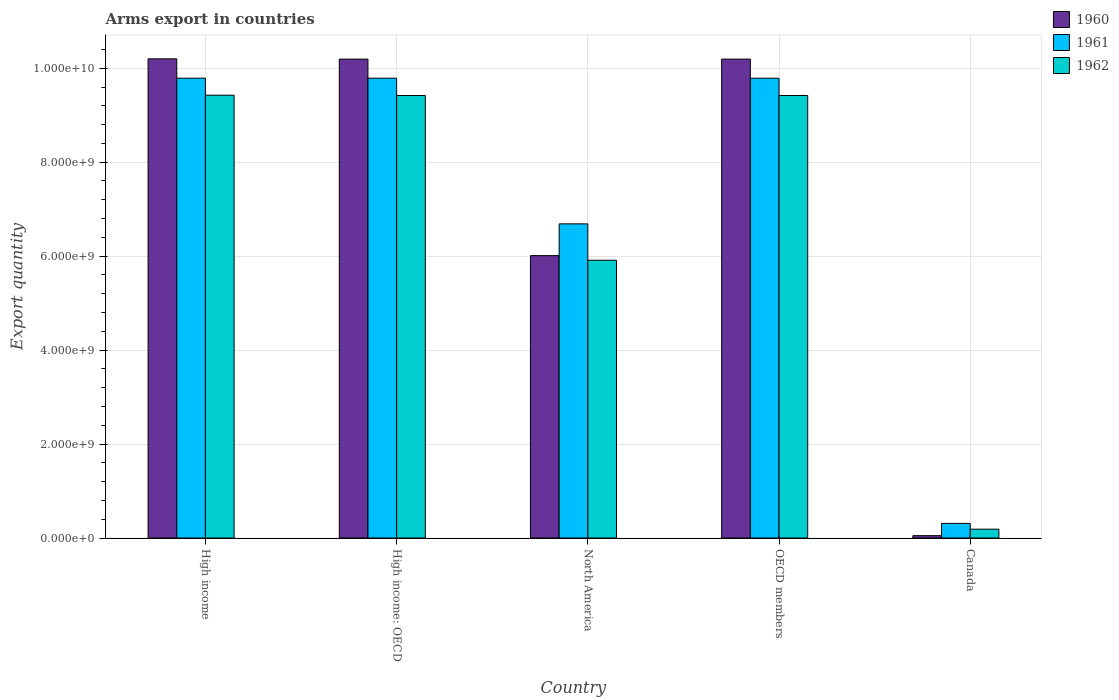Are the number of bars per tick equal to the number of legend labels?
Keep it short and to the point. Yes. How many bars are there on the 1st tick from the left?
Your response must be concise. 3. What is the label of the 3rd group of bars from the left?
Your answer should be compact. North America. What is the total arms export in 1962 in High income?
Provide a succinct answer. 9.43e+09. Across all countries, what is the maximum total arms export in 1961?
Offer a very short reply. 9.79e+09. Across all countries, what is the minimum total arms export in 1960?
Keep it short and to the point. 5.00e+07. In which country was the total arms export in 1962 minimum?
Your answer should be compact. Canada. What is the total total arms export in 1961 in the graph?
Your answer should be compact. 3.64e+1. What is the difference between the total arms export in 1961 in High income and that in OECD members?
Your response must be concise. 0. What is the difference between the total arms export in 1960 in High income and the total arms export in 1962 in North America?
Your answer should be very brief. 4.29e+09. What is the average total arms export in 1962 per country?
Make the answer very short. 6.87e+09. What is the difference between the total arms export of/in 1961 and total arms export of/in 1960 in Canada?
Your answer should be compact. 2.61e+08. In how many countries, is the total arms export in 1962 greater than 7600000000?
Keep it short and to the point. 3. What is the ratio of the total arms export in 1962 in High income to that in OECD members?
Offer a very short reply. 1. Is the difference between the total arms export in 1961 in Canada and North America greater than the difference between the total arms export in 1960 in Canada and North America?
Give a very brief answer. No. What is the difference between the highest and the lowest total arms export in 1960?
Give a very brief answer. 1.02e+1. In how many countries, is the total arms export in 1960 greater than the average total arms export in 1960 taken over all countries?
Keep it short and to the point. 3. Is it the case that in every country, the sum of the total arms export in 1960 and total arms export in 1962 is greater than the total arms export in 1961?
Your response must be concise. No. How many bars are there?
Offer a very short reply. 15. Are all the bars in the graph horizontal?
Make the answer very short. No. Are the values on the major ticks of Y-axis written in scientific E-notation?
Provide a succinct answer. Yes. How many legend labels are there?
Make the answer very short. 3. What is the title of the graph?
Ensure brevity in your answer.  Arms export in countries. Does "2007" appear as one of the legend labels in the graph?
Provide a succinct answer. No. What is the label or title of the Y-axis?
Offer a terse response. Export quantity. What is the Export quantity of 1960 in High income?
Your answer should be very brief. 1.02e+1. What is the Export quantity in 1961 in High income?
Make the answer very short. 9.79e+09. What is the Export quantity in 1962 in High income?
Give a very brief answer. 9.43e+09. What is the Export quantity in 1960 in High income: OECD?
Your answer should be very brief. 1.02e+1. What is the Export quantity of 1961 in High income: OECD?
Your response must be concise. 9.79e+09. What is the Export quantity of 1962 in High income: OECD?
Your answer should be very brief. 9.42e+09. What is the Export quantity of 1960 in North America?
Give a very brief answer. 6.01e+09. What is the Export quantity in 1961 in North America?
Make the answer very short. 6.69e+09. What is the Export quantity of 1962 in North America?
Provide a short and direct response. 5.91e+09. What is the Export quantity of 1960 in OECD members?
Make the answer very short. 1.02e+1. What is the Export quantity of 1961 in OECD members?
Keep it short and to the point. 9.79e+09. What is the Export quantity in 1962 in OECD members?
Make the answer very short. 9.42e+09. What is the Export quantity in 1961 in Canada?
Your response must be concise. 3.11e+08. What is the Export quantity of 1962 in Canada?
Provide a short and direct response. 1.88e+08. Across all countries, what is the maximum Export quantity of 1960?
Your response must be concise. 1.02e+1. Across all countries, what is the maximum Export quantity of 1961?
Your answer should be very brief. 9.79e+09. Across all countries, what is the maximum Export quantity of 1962?
Give a very brief answer. 9.43e+09. Across all countries, what is the minimum Export quantity in 1960?
Give a very brief answer. 5.00e+07. Across all countries, what is the minimum Export quantity of 1961?
Offer a terse response. 3.11e+08. Across all countries, what is the minimum Export quantity of 1962?
Provide a succinct answer. 1.88e+08. What is the total Export quantity in 1960 in the graph?
Your answer should be very brief. 3.66e+1. What is the total Export quantity in 1961 in the graph?
Provide a short and direct response. 3.64e+1. What is the total Export quantity in 1962 in the graph?
Provide a succinct answer. 3.44e+1. What is the difference between the Export quantity of 1961 in High income and that in High income: OECD?
Give a very brief answer. 0. What is the difference between the Export quantity in 1962 in High income and that in High income: OECD?
Provide a succinct answer. 6.00e+06. What is the difference between the Export quantity in 1960 in High income and that in North America?
Your response must be concise. 4.19e+09. What is the difference between the Export quantity of 1961 in High income and that in North America?
Ensure brevity in your answer.  3.10e+09. What is the difference between the Export quantity of 1962 in High income and that in North America?
Keep it short and to the point. 3.51e+09. What is the difference between the Export quantity in 1960 in High income and that in OECD members?
Keep it short and to the point. 6.00e+06. What is the difference between the Export quantity in 1962 in High income and that in OECD members?
Keep it short and to the point. 6.00e+06. What is the difference between the Export quantity in 1960 in High income and that in Canada?
Your response must be concise. 1.02e+1. What is the difference between the Export quantity in 1961 in High income and that in Canada?
Offer a terse response. 9.48e+09. What is the difference between the Export quantity of 1962 in High income and that in Canada?
Provide a short and direct response. 9.24e+09. What is the difference between the Export quantity of 1960 in High income: OECD and that in North America?
Your response must be concise. 4.18e+09. What is the difference between the Export quantity of 1961 in High income: OECD and that in North America?
Provide a short and direct response. 3.10e+09. What is the difference between the Export quantity in 1962 in High income: OECD and that in North America?
Your answer should be very brief. 3.51e+09. What is the difference between the Export quantity of 1960 in High income: OECD and that in OECD members?
Offer a very short reply. 0. What is the difference between the Export quantity of 1962 in High income: OECD and that in OECD members?
Provide a short and direct response. 0. What is the difference between the Export quantity in 1960 in High income: OECD and that in Canada?
Provide a succinct answer. 1.01e+1. What is the difference between the Export quantity of 1961 in High income: OECD and that in Canada?
Give a very brief answer. 9.48e+09. What is the difference between the Export quantity in 1962 in High income: OECD and that in Canada?
Give a very brief answer. 9.23e+09. What is the difference between the Export quantity of 1960 in North America and that in OECD members?
Your answer should be very brief. -4.18e+09. What is the difference between the Export quantity in 1961 in North America and that in OECD members?
Offer a very short reply. -3.10e+09. What is the difference between the Export quantity of 1962 in North America and that in OECD members?
Provide a short and direct response. -3.51e+09. What is the difference between the Export quantity in 1960 in North America and that in Canada?
Ensure brevity in your answer.  5.96e+09. What is the difference between the Export quantity of 1961 in North America and that in Canada?
Provide a succinct answer. 6.38e+09. What is the difference between the Export quantity of 1962 in North America and that in Canada?
Your answer should be very brief. 5.72e+09. What is the difference between the Export quantity in 1960 in OECD members and that in Canada?
Give a very brief answer. 1.01e+1. What is the difference between the Export quantity in 1961 in OECD members and that in Canada?
Ensure brevity in your answer.  9.48e+09. What is the difference between the Export quantity of 1962 in OECD members and that in Canada?
Offer a very short reply. 9.23e+09. What is the difference between the Export quantity in 1960 in High income and the Export quantity in 1961 in High income: OECD?
Offer a terse response. 4.12e+08. What is the difference between the Export quantity in 1960 in High income and the Export quantity in 1962 in High income: OECD?
Ensure brevity in your answer.  7.80e+08. What is the difference between the Export quantity in 1961 in High income and the Export quantity in 1962 in High income: OECD?
Your answer should be compact. 3.68e+08. What is the difference between the Export quantity of 1960 in High income and the Export quantity of 1961 in North America?
Your answer should be very brief. 3.51e+09. What is the difference between the Export quantity of 1960 in High income and the Export quantity of 1962 in North America?
Provide a short and direct response. 4.29e+09. What is the difference between the Export quantity of 1961 in High income and the Export quantity of 1962 in North America?
Provide a succinct answer. 3.88e+09. What is the difference between the Export quantity in 1960 in High income and the Export quantity in 1961 in OECD members?
Offer a very short reply. 4.12e+08. What is the difference between the Export quantity in 1960 in High income and the Export quantity in 1962 in OECD members?
Your response must be concise. 7.80e+08. What is the difference between the Export quantity of 1961 in High income and the Export quantity of 1962 in OECD members?
Provide a short and direct response. 3.68e+08. What is the difference between the Export quantity of 1960 in High income and the Export quantity of 1961 in Canada?
Keep it short and to the point. 9.89e+09. What is the difference between the Export quantity of 1960 in High income and the Export quantity of 1962 in Canada?
Your answer should be compact. 1.00e+1. What is the difference between the Export quantity in 1961 in High income and the Export quantity in 1962 in Canada?
Make the answer very short. 9.60e+09. What is the difference between the Export quantity of 1960 in High income: OECD and the Export quantity of 1961 in North America?
Offer a very short reply. 3.51e+09. What is the difference between the Export quantity of 1960 in High income: OECD and the Export quantity of 1962 in North America?
Ensure brevity in your answer.  4.28e+09. What is the difference between the Export quantity of 1961 in High income: OECD and the Export quantity of 1962 in North America?
Ensure brevity in your answer.  3.88e+09. What is the difference between the Export quantity in 1960 in High income: OECD and the Export quantity in 1961 in OECD members?
Provide a succinct answer. 4.06e+08. What is the difference between the Export quantity of 1960 in High income: OECD and the Export quantity of 1962 in OECD members?
Offer a very short reply. 7.74e+08. What is the difference between the Export quantity in 1961 in High income: OECD and the Export quantity in 1962 in OECD members?
Ensure brevity in your answer.  3.68e+08. What is the difference between the Export quantity of 1960 in High income: OECD and the Export quantity of 1961 in Canada?
Provide a succinct answer. 9.88e+09. What is the difference between the Export quantity of 1960 in High income: OECD and the Export quantity of 1962 in Canada?
Keep it short and to the point. 1.00e+1. What is the difference between the Export quantity of 1961 in High income: OECD and the Export quantity of 1962 in Canada?
Give a very brief answer. 9.60e+09. What is the difference between the Export quantity of 1960 in North America and the Export quantity of 1961 in OECD members?
Provide a succinct answer. -3.78e+09. What is the difference between the Export quantity of 1960 in North America and the Export quantity of 1962 in OECD members?
Your answer should be compact. -3.41e+09. What is the difference between the Export quantity of 1961 in North America and the Export quantity of 1962 in OECD members?
Make the answer very short. -2.73e+09. What is the difference between the Export quantity in 1960 in North America and the Export quantity in 1961 in Canada?
Ensure brevity in your answer.  5.70e+09. What is the difference between the Export quantity in 1960 in North America and the Export quantity in 1962 in Canada?
Your response must be concise. 5.82e+09. What is the difference between the Export quantity of 1961 in North America and the Export quantity of 1962 in Canada?
Offer a very short reply. 6.50e+09. What is the difference between the Export quantity of 1960 in OECD members and the Export quantity of 1961 in Canada?
Your answer should be very brief. 9.88e+09. What is the difference between the Export quantity of 1960 in OECD members and the Export quantity of 1962 in Canada?
Make the answer very short. 1.00e+1. What is the difference between the Export quantity of 1961 in OECD members and the Export quantity of 1962 in Canada?
Provide a succinct answer. 9.60e+09. What is the average Export quantity of 1960 per country?
Ensure brevity in your answer.  7.33e+09. What is the average Export quantity in 1961 per country?
Make the answer very short. 7.27e+09. What is the average Export quantity of 1962 per country?
Keep it short and to the point. 6.87e+09. What is the difference between the Export quantity in 1960 and Export quantity in 1961 in High income?
Your answer should be very brief. 4.12e+08. What is the difference between the Export quantity of 1960 and Export quantity of 1962 in High income?
Provide a succinct answer. 7.74e+08. What is the difference between the Export quantity in 1961 and Export quantity in 1962 in High income?
Your answer should be compact. 3.62e+08. What is the difference between the Export quantity in 1960 and Export quantity in 1961 in High income: OECD?
Provide a short and direct response. 4.06e+08. What is the difference between the Export quantity of 1960 and Export quantity of 1962 in High income: OECD?
Keep it short and to the point. 7.74e+08. What is the difference between the Export quantity in 1961 and Export quantity in 1962 in High income: OECD?
Offer a terse response. 3.68e+08. What is the difference between the Export quantity of 1960 and Export quantity of 1961 in North America?
Keep it short and to the point. -6.76e+08. What is the difference between the Export quantity in 1960 and Export quantity in 1962 in North America?
Keep it short and to the point. 9.80e+07. What is the difference between the Export quantity of 1961 and Export quantity of 1962 in North America?
Offer a very short reply. 7.74e+08. What is the difference between the Export quantity of 1960 and Export quantity of 1961 in OECD members?
Your response must be concise. 4.06e+08. What is the difference between the Export quantity of 1960 and Export quantity of 1962 in OECD members?
Keep it short and to the point. 7.74e+08. What is the difference between the Export quantity of 1961 and Export quantity of 1962 in OECD members?
Your response must be concise. 3.68e+08. What is the difference between the Export quantity in 1960 and Export quantity in 1961 in Canada?
Make the answer very short. -2.61e+08. What is the difference between the Export quantity in 1960 and Export quantity in 1962 in Canada?
Your answer should be very brief. -1.38e+08. What is the difference between the Export quantity in 1961 and Export quantity in 1962 in Canada?
Make the answer very short. 1.23e+08. What is the ratio of the Export quantity of 1961 in High income to that in High income: OECD?
Your answer should be very brief. 1. What is the ratio of the Export quantity in 1962 in High income to that in High income: OECD?
Your answer should be very brief. 1. What is the ratio of the Export quantity in 1960 in High income to that in North America?
Your response must be concise. 1.7. What is the ratio of the Export quantity of 1961 in High income to that in North America?
Give a very brief answer. 1.46. What is the ratio of the Export quantity of 1962 in High income to that in North America?
Your response must be concise. 1.59. What is the ratio of the Export quantity of 1960 in High income to that in OECD members?
Ensure brevity in your answer.  1. What is the ratio of the Export quantity in 1962 in High income to that in OECD members?
Make the answer very short. 1. What is the ratio of the Export quantity of 1960 in High income to that in Canada?
Offer a terse response. 204. What is the ratio of the Export quantity in 1961 in High income to that in Canada?
Offer a very short reply. 31.47. What is the ratio of the Export quantity in 1962 in High income to that in Canada?
Your answer should be compact. 50.14. What is the ratio of the Export quantity in 1960 in High income: OECD to that in North America?
Your response must be concise. 1.7. What is the ratio of the Export quantity of 1961 in High income: OECD to that in North America?
Make the answer very short. 1.46. What is the ratio of the Export quantity in 1962 in High income: OECD to that in North America?
Provide a succinct answer. 1.59. What is the ratio of the Export quantity of 1962 in High income: OECD to that in OECD members?
Provide a succinct answer. 1. What is the ratio of the Export quantity of 1960 in High income: OECD to that in Canada?
Offer a terse response. 203.88. What is the ratio of the Export quantity in 1961 in High income: OECD to that in Canada?
Your answer should be very brief. 31.47. What is the ratio of the Export quantity of 1962 in High income: OECD to that in Canada?
Your answer should be very brief. 50.11. What is the ratio of the Export quantity in 1960 in North America to that in OECD members?
Make the answer very short. 0.59. What is the ratio of the Export quantity of 1961 in North America to that in OECD members?
Give a very brief answer. 0.68. What is the ratio of the Export quantity of 1962 in North America to that in OECD members?
Offer a terse response. 0.63. What is the ratio of the Export quantity of 1960 in North America to that in Canada?
Your response must be concise. 120.22. What is the ratio of the Export quantity of 1961 in North America to that in Canada?
Your answer should be very brief. 21.5. What is the ratio of the Export quantity in 1962 in North America to that in Canada?
Offer a very short reply. 31.45. What is the ratio of the Export quantity of 1960 in OECD members to that in Canada?
Provide a short and direct response. 203.88. What is the ratio of the Export quantity of 1961 in OECD members to that in Canada?
Your response must be concise. 31.47. What is the ratio of the Export quantity in 1962 in OECD members to that in Canada?
Provide a short and direct response. 50.11. What is the difference between the highest and the second highest Export quantity of 1960?
Your response must be concise. 6.00e+06. What is the difference between the highest and the second highest Export quantity of 1961?
Offer a terse response. 0. What is the difference between the highest and the lowest Export quantity of 1960?
Ensure brevity in your answer.  1.02e+1. What is the difference between the highest and the lowest Export quantity in 1961?
Offer a terse response. 9.48e+09. What is the difference between the highest and the lowest Export quantity of 1962?
Ensure brevity in your answer.  9.24e+09. 